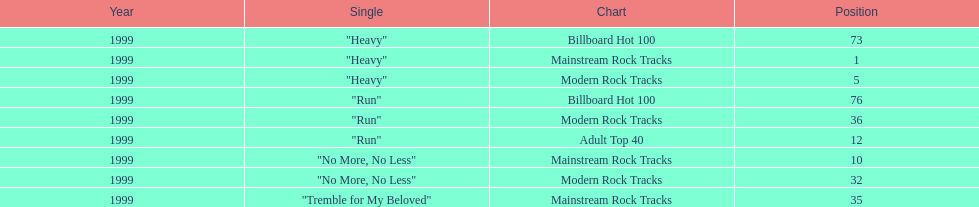What is the total number of charts "run" made it onto? 3. 